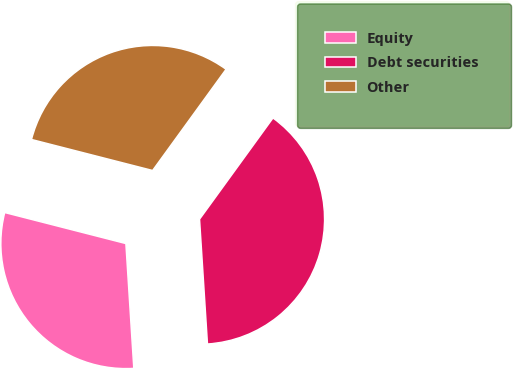Convert chart to OTSL. <chart><loc_0><loc_0><loc_500><loc_500><pie_chart><fcel>Equity<fcel>Debt securities<fcel>Other<nl><fcel>30.0%<fcel>39.0%<fcel>31.0%<nl></chart> 